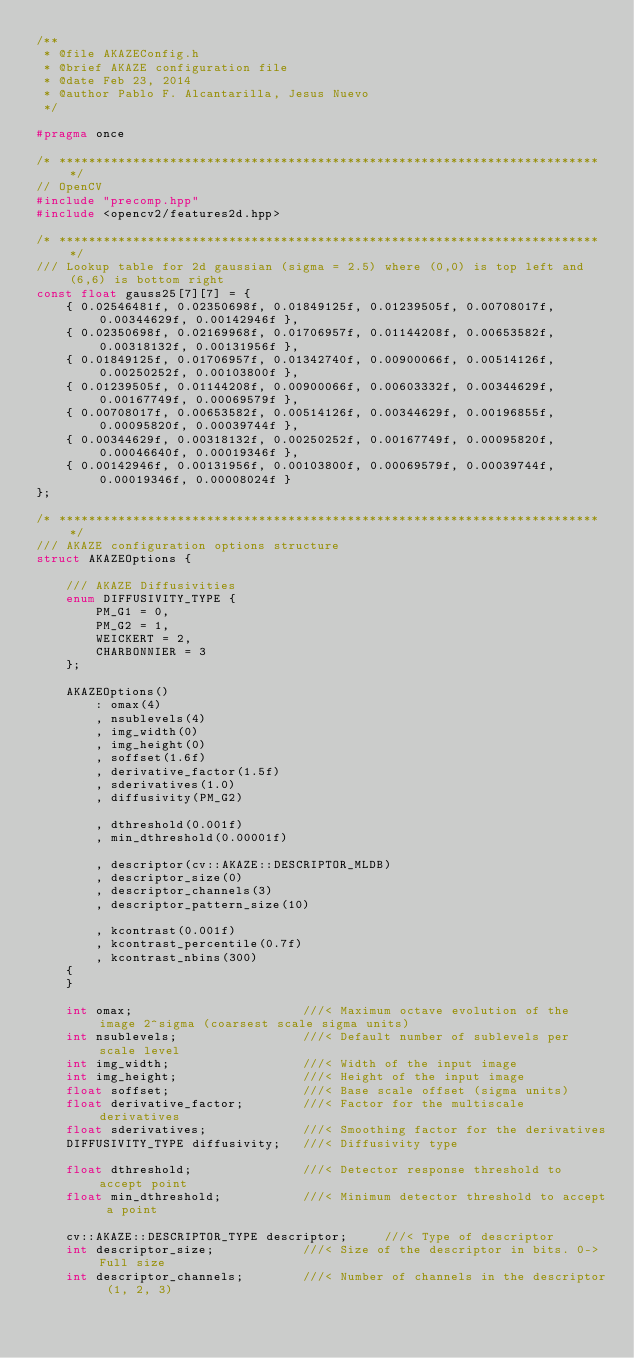Convert code to text. <code><loc_0><loc_0><loc_500><loc_500><_C_>/**
 * @file AKAZEConfig.h
 * @brief AKAZE configuration file
 * @date Feb 23, 2014
 * @author Pablo F. Alcantarilla, Jesus Nuevo
 */

#pragma once

/* ************************************************************************* */
// OpenCV
#include "precomp.hpp"
#include <opencv2/features2d.hpp>

/* ************************************************************************* */
/// Lookup table for 2d gaussian (sigma = 2.5) where (0,0) is top left and (6,6) is bottom right
const float gauss25[7][7] = {
    { 0.02546481f, 0.02350698f, 0.01849125f, 0.01239505f, 0.00708017f, 0.00344629f, 0.00142946f },
    { 0.02350698f, 0.02169968f, 0.01706957f, 0.01144208f, 0.00653582f, 0.00318132f, 0.00131956f },
    { 0.01849125f, 0.01706957f, 0.01342740f, 0.00900066f, 0.00514126f, 0.00250252f, 0.00103800f },
    { 0.01239505f, 0.01144208f, 0.00900066f, 0.00603332f, 0.00344629f, 0.00167749f, 0.00069579f },
    { 0.00708017f, 0.00653582f, 0.00514126f, 0.00344629f, 0.00196855f, 0.00095820f, 0.00039744f },
    { 0.00344629f, 0.00318132f, 0.00250252f, 0.00167749f, 0.00095820f, 0.00046640f, 0.00019346f },
    { 0.00142946f, 0.00131956f, 0.00103800f, 0.00069579f, 0.00039744f, 0.00019346f, 0.00008024f }
};

/* ************************************************************************* */
/// AKAZE configuration options structure
struct AKAZEOptions {

    /// AKAZE Diffusivities
    enum DIFFUSIVITY_TYPE {
        PM_G1 = 0,
        PM_G2 = 1,
        WEICKERT = 2,
        CHARBONNIER = 3
    };

    AKAZEOptions()
        : omax(4)
        , nsublevels(4)
        , img_width(0)
        , img_height(0)
        , soffset(1.6f)
        , derivative_factor(1.5f)
        , sderivatives(1.0)
        , diffusivity(PM_G2)

        , dthreshold(0.001f)
        , min_dthreshold(0.00001f)

        , descriptor(cv::AKAZE::DESCRIPTOR_MLDB)
        , descriptor_size(0)
        , descriptor_channels(3)
        , descriptor_pattern_size(10)

        , kcontrast(0.001f)
        , kcontrast_percentile(0.7f)
        , kcontrast_nbins(300)
    {
    }

    int omax;                       ///< Maximum octave evolution of the image 2^sigma (coarsest scale sigma units)
    int nsublevels;                 ///< Default number of sublevels per scale level
    int img_width;                  ///< Width of the input image
    int img_height;                 ///< Height of the input image
    float soffset;                  ///< Base scale offset (sigma units)
    float derivative_factor;        ///< Factor for the multiscale derivatives
    float sderivatives;             ///< Smoothing factor for the derivatives
    DIFFUSIVITY_TYPE diffusivity;   ///< Diffusivity type

    float dthreshold;               ///< Detector response threshold to accept point
    float min_dthreshold;           ///< Minimum detector threshold to accept a point

    cv::AKAZE::DESCRIPTOR_TYPE descriptor;     ///< Type of descriptor
    int descriptor_size;            ///< Size of the descriptor in bits. 0->Full size
    int descriptor_channels;        ///< Number of channels in the descriptor (1, 2, 3)</code> 